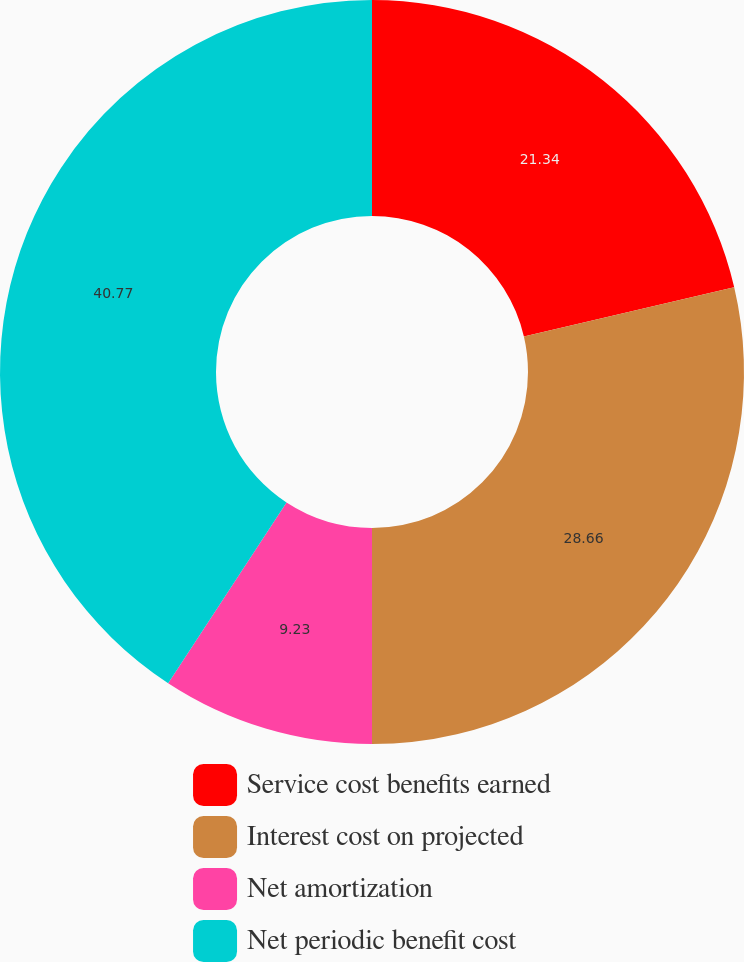Convert chart to OTSL. <chart><loc_0><loc_0><loc_500><loc_500><pie_chart><fcel>Service cost benefits earned<fcel>Interest cost on projected<fcel>Net amortization<fcel>Net periodic benefit cost<nl><fcel>21.34%<fcel>28.66%<fcel>9.23%<fcel>40.77%<nl></chart> 